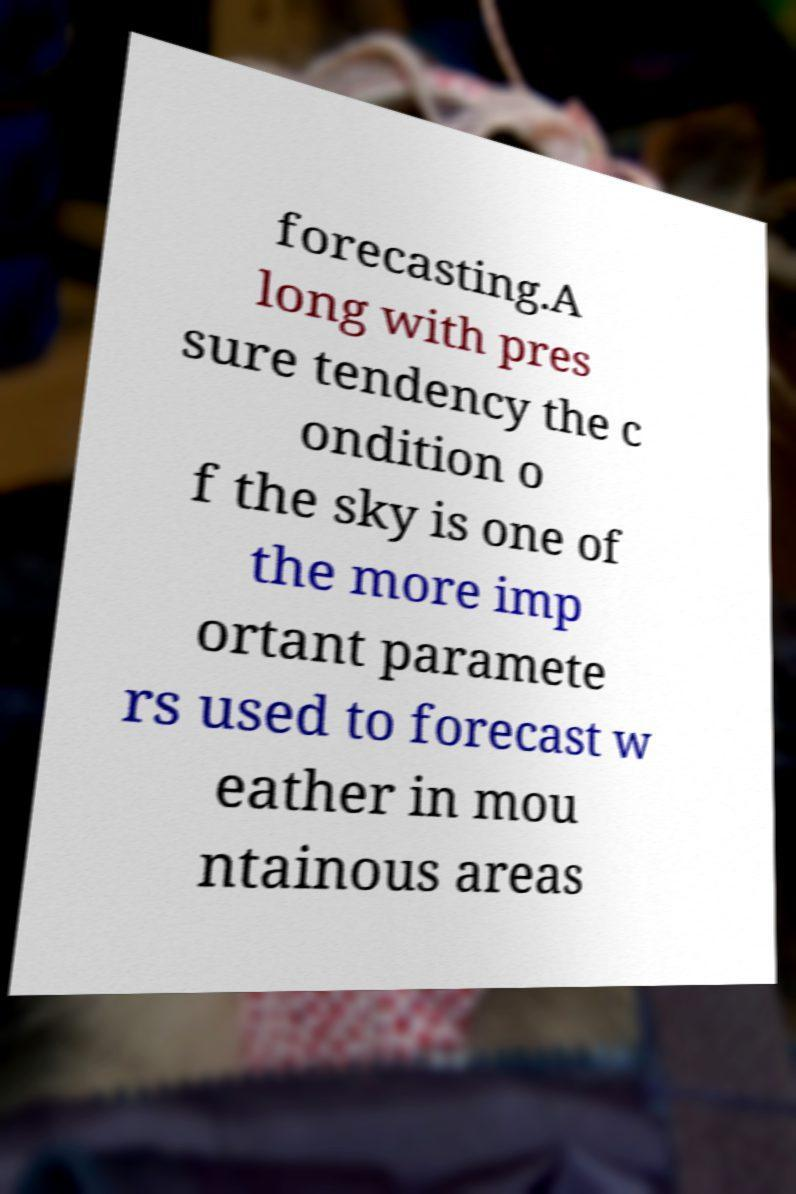Could you extract and type out the text from this image? forecasting.A long with pres sure tendency the c ondition o f the sky is one of the more imp ortant paramete rs used to forecast w eather in mou ntainous areas 